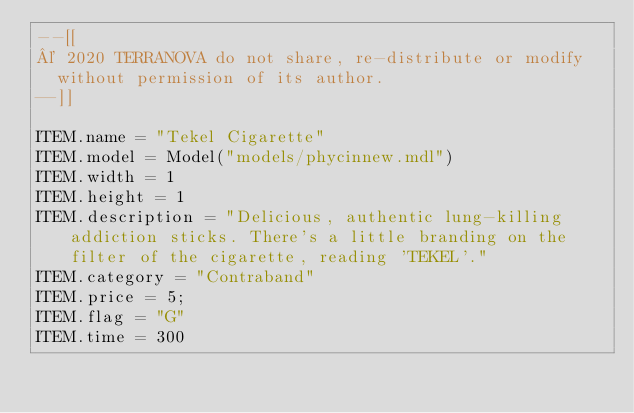<code> <loc_0><loc_0><loc_500><loc_500><_Lua_>--[[
© 2020 TERRANOVA do not share, re-distribute or modify
	without permission of its author.
--]]

ITEM.name = "Tekel Cigarette"
ITEM.model = Model("models/phycinnew.mdl")
ITEM.width = 1
ITEM.height = 1
ITEM.description = "Delicious, authentic lung-killing addiction sticks. There's a little branding on the filter of the cigarette, reading 'TEKEL'."
ITEM.category = "Contraband"
ITEM.price = 5;
ITEM.flag = "G"
ITEM.time = 300</code> 